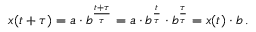<formula> <loc_0><loc_0><loc_500><loc_500>x ( t + \tau ) = a \cdot b ^ { \frac { t + \tau } { \tau } } = a \cdot b ^ { \frac { t } { \tau } } \cdot b ^ { \frac { \tau } { \tau } } = x ( t ) \cdot b \, .</formula> 